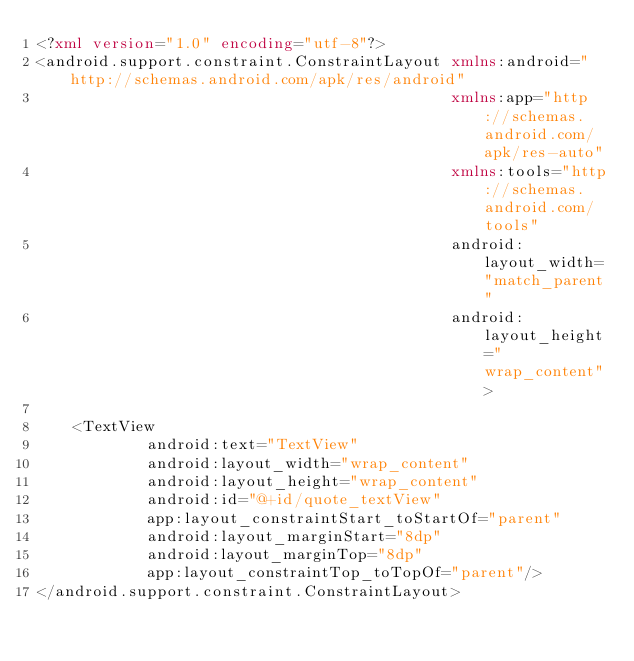<code> <loc_0><loc_0><loc_500><loc_500><_XML_><?xml version="1.0" encoding="utf-8"?>
<android.support.constraint.ConstraintLayout xmlns:android="http://schemas.android.com/apk/res/android"
                                             xmlns:app="http://schemas.android.com/apk/res-auto"
                                             xmlns:tools="http://schemas.android.com/tools"
                                             android:layout_width="match_parent"
                                             android:layout_height="wrap_content">

    <TextView
            android:text="TextView"
            android:layout_width="wrap_content"
            android:layout_height="wrap_content"
            android:id="@+id/quote_textView"
            app:layout_constraintStart_toStartOf="parent"
            android:layout_marginStart="8dp"
            android:layout_marginTop="8dp"
            app:layout_constraintTop_toTopOf="parent"/>
</android.support.constraint.ConstraintLayout></code> 